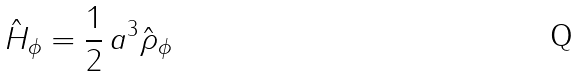Convert formula to latex. <formula><loc_0><loc_0><loc_500><loc_500>\hat { H } _ { \phi } = \frac { 1 } { 2 } \, a ^ { 3 } \hat { \rho } _ { \phi }</formula> 